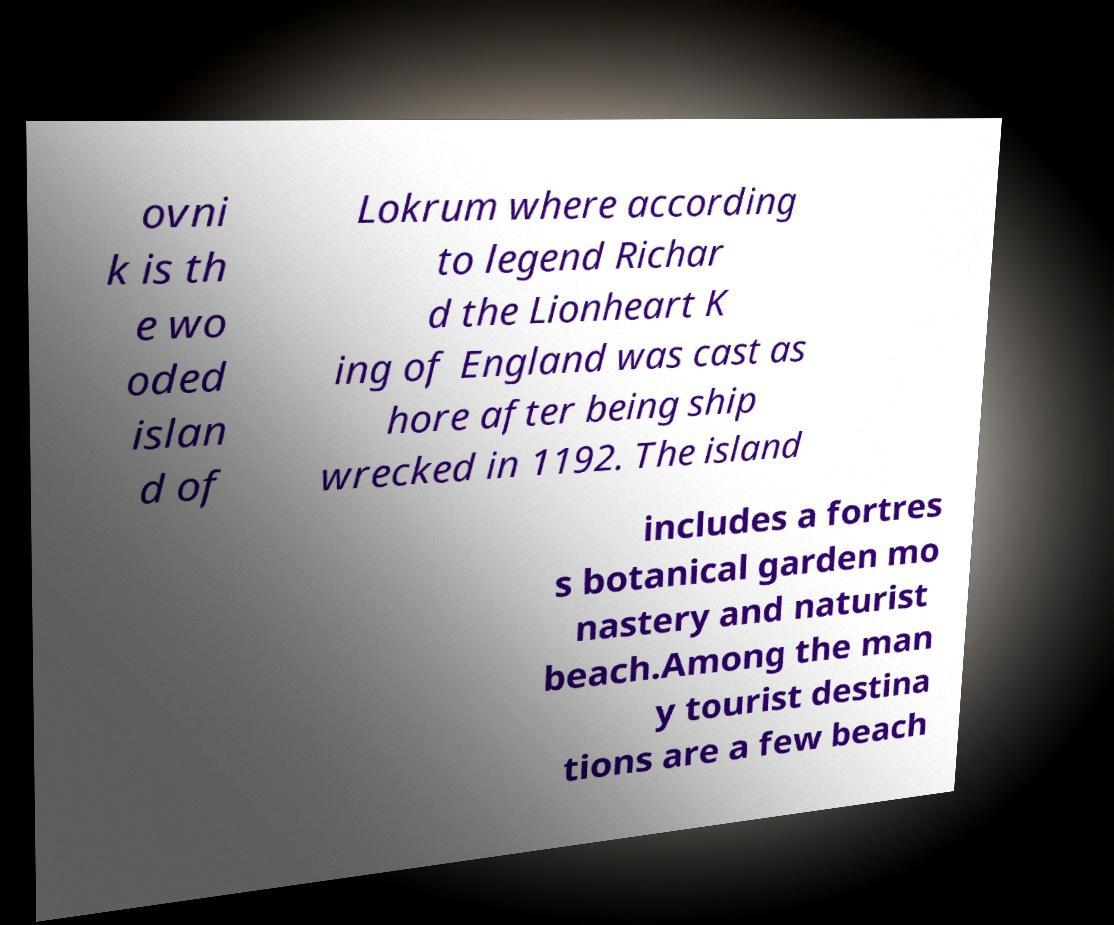What messages or text are displayed in this image? I need them in a readable, typed format. ovni k is th e wo oded islan d of Lokrum where according to legend Richar d the Lionheart K ing of England was cast as hore after being ship wrecked in 1192. The island includes a fortres s botanical garden mo nastery and naturist beach.Among the man y tourist destina tions are a few beach 